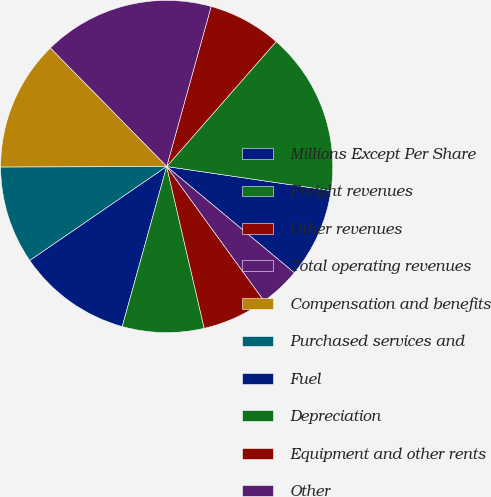Convert chart. <chart><loc_0><loc_0><loc_500><loc_500><pie_chart><fcel>Millions Except Per Share<fcel>Freight revenues<fcel>Other revenues<fcel>Total operating revenues<fcel>Compensation and benefits<fcel>Purchased services and<fcel>Fuel<fcel>Depreciation<fcel>Equipment and other rents<fcel>Other<nl><fcel>8.73%<fcel>15.87%<fcel>7.14%<fcel>16.67%<fcel>12.7%<fcel>9.52%<fcel>11.11%<fcel>7.94%<fcel>6.35%<fcel>3.97%<nl></chart> 